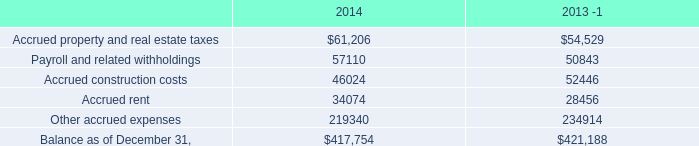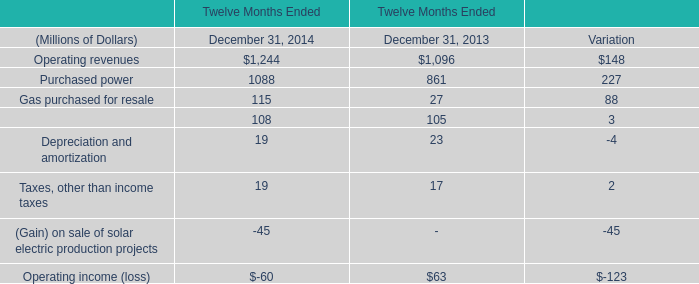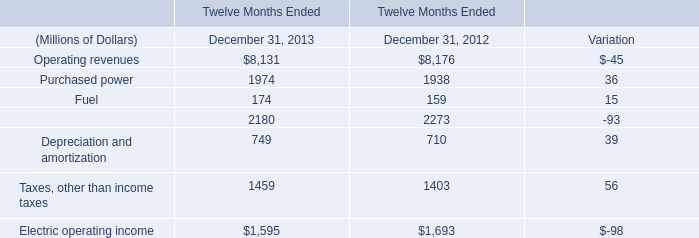what's the total amount of Purchased power of Twelve Months Ended December 31, 2012, and Accrued rent of 2014 ? 
Computations: (1938.0 + 34074.0)
Answer: 36012.0. 